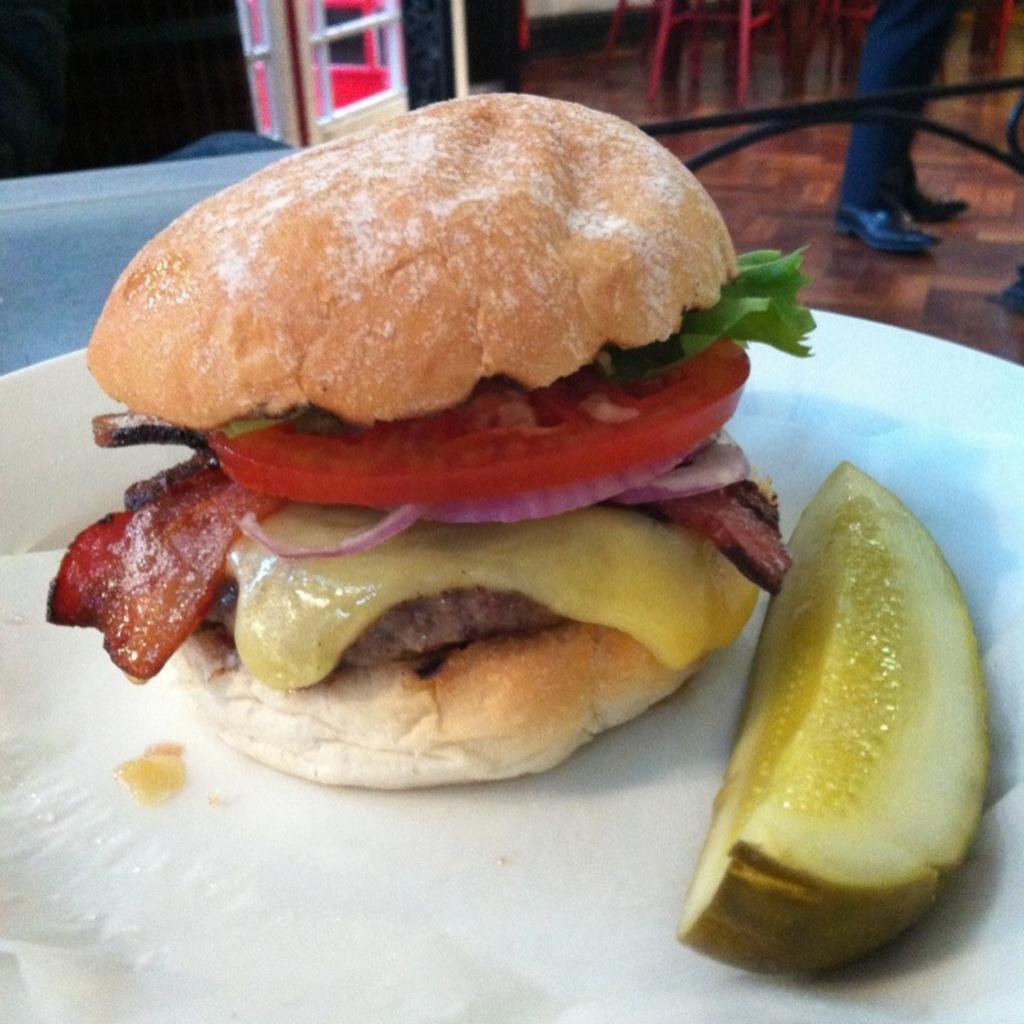How would you summarize this image in a sentence or two? In this image we can see some food items on the plate, there are chairs, also we can see the legs of a person. 